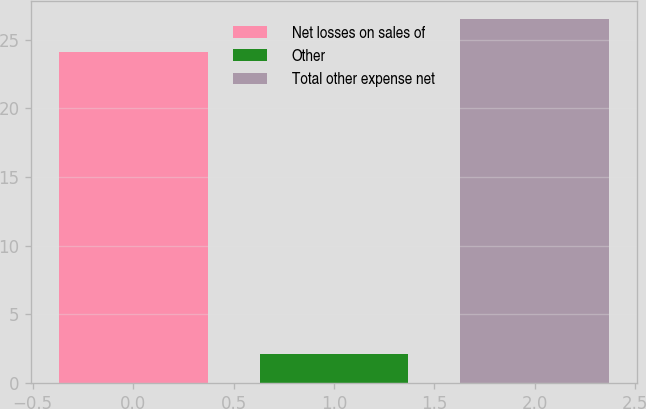<chart> <loc_0><loc_0><loc_500><loc_500><bar_chart><fcel>Net losses on sales of<fcel>Other<fcel>Total other expense net<nl><fcel>24.1<fcel>2.1<fcel>26.51<nl></chart> 